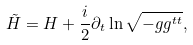<formula> <loc_0><loc_0><loc_500><loc_500>\tilde { H } = H + \frac { i } { 2 } \partial _ { t } \ln \sqrt { - g g ^ { t t } } ,</formula> 